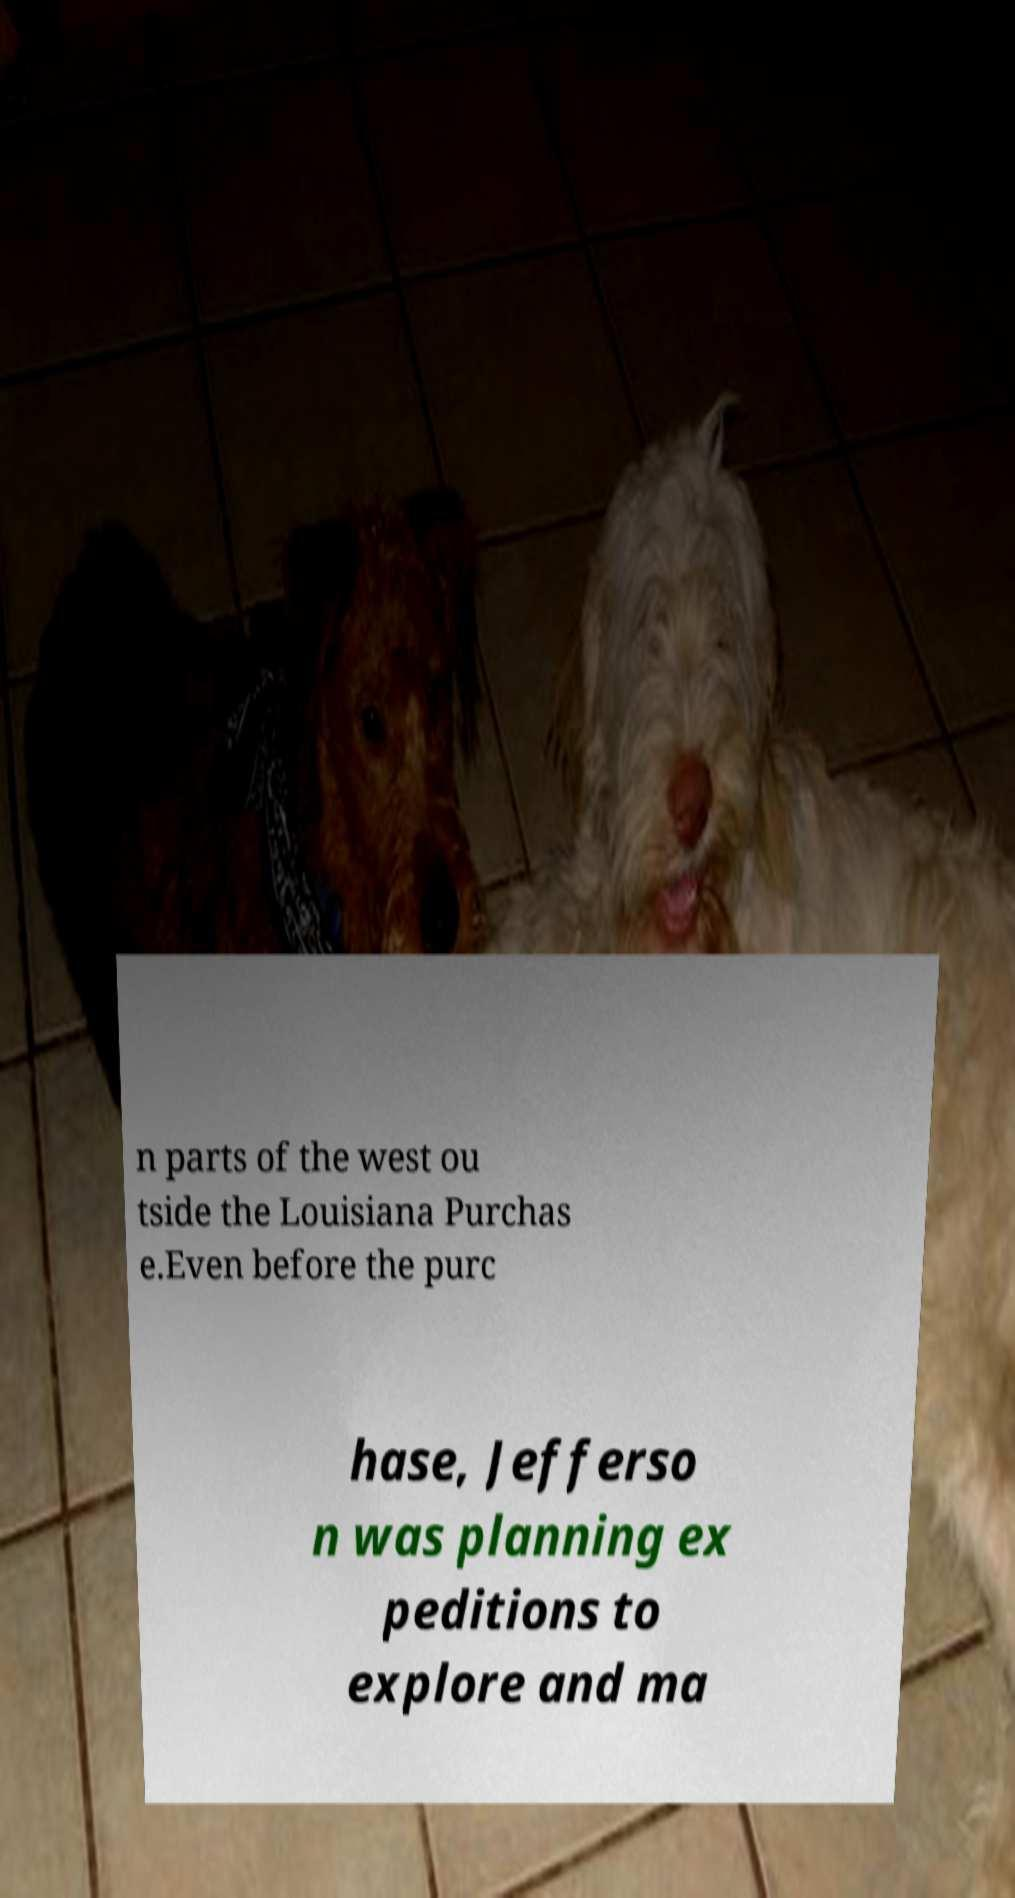Please identify and transcribe the text found in this image. n parts of the west ou tside the Louisiana Purchas e.Even before the purc hase, Jefferso n was planning ex peditions to explore and ma 